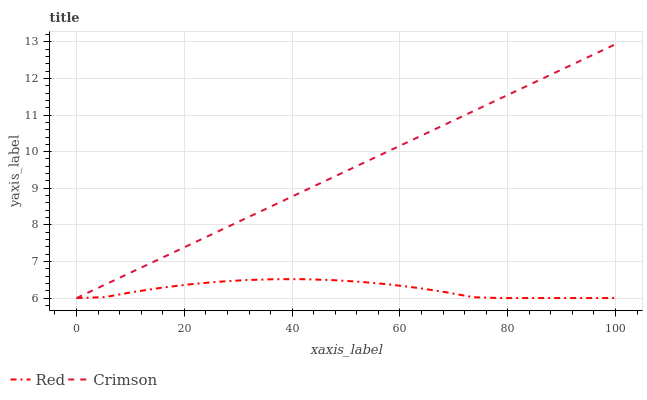Does Red have the minimum area under the curve?
Answer yes or no. Yes. Does Crimson have the maximum area under the curve?
Answer yes or no. Yes. Does Red have the maximum area under the curve?
Answer yes or no. No. Is Crimson the smoothest?
Answer yes or no. Yes. Is Red the roughest?
Answer yes or no. Yes. Is Red the smoothest?
Answer yes or no. No. Does Crimson have the highest value?
Answer yes or no. Yes. Does Red have the highest value?
Answer yes or no. No. Does Red intersect Crimson?
Answer yes or no. Yes. Is Red less than Crimson?
Answer yes or no. No. Is Red greater than Crimson?
Answer yes or no. No. 